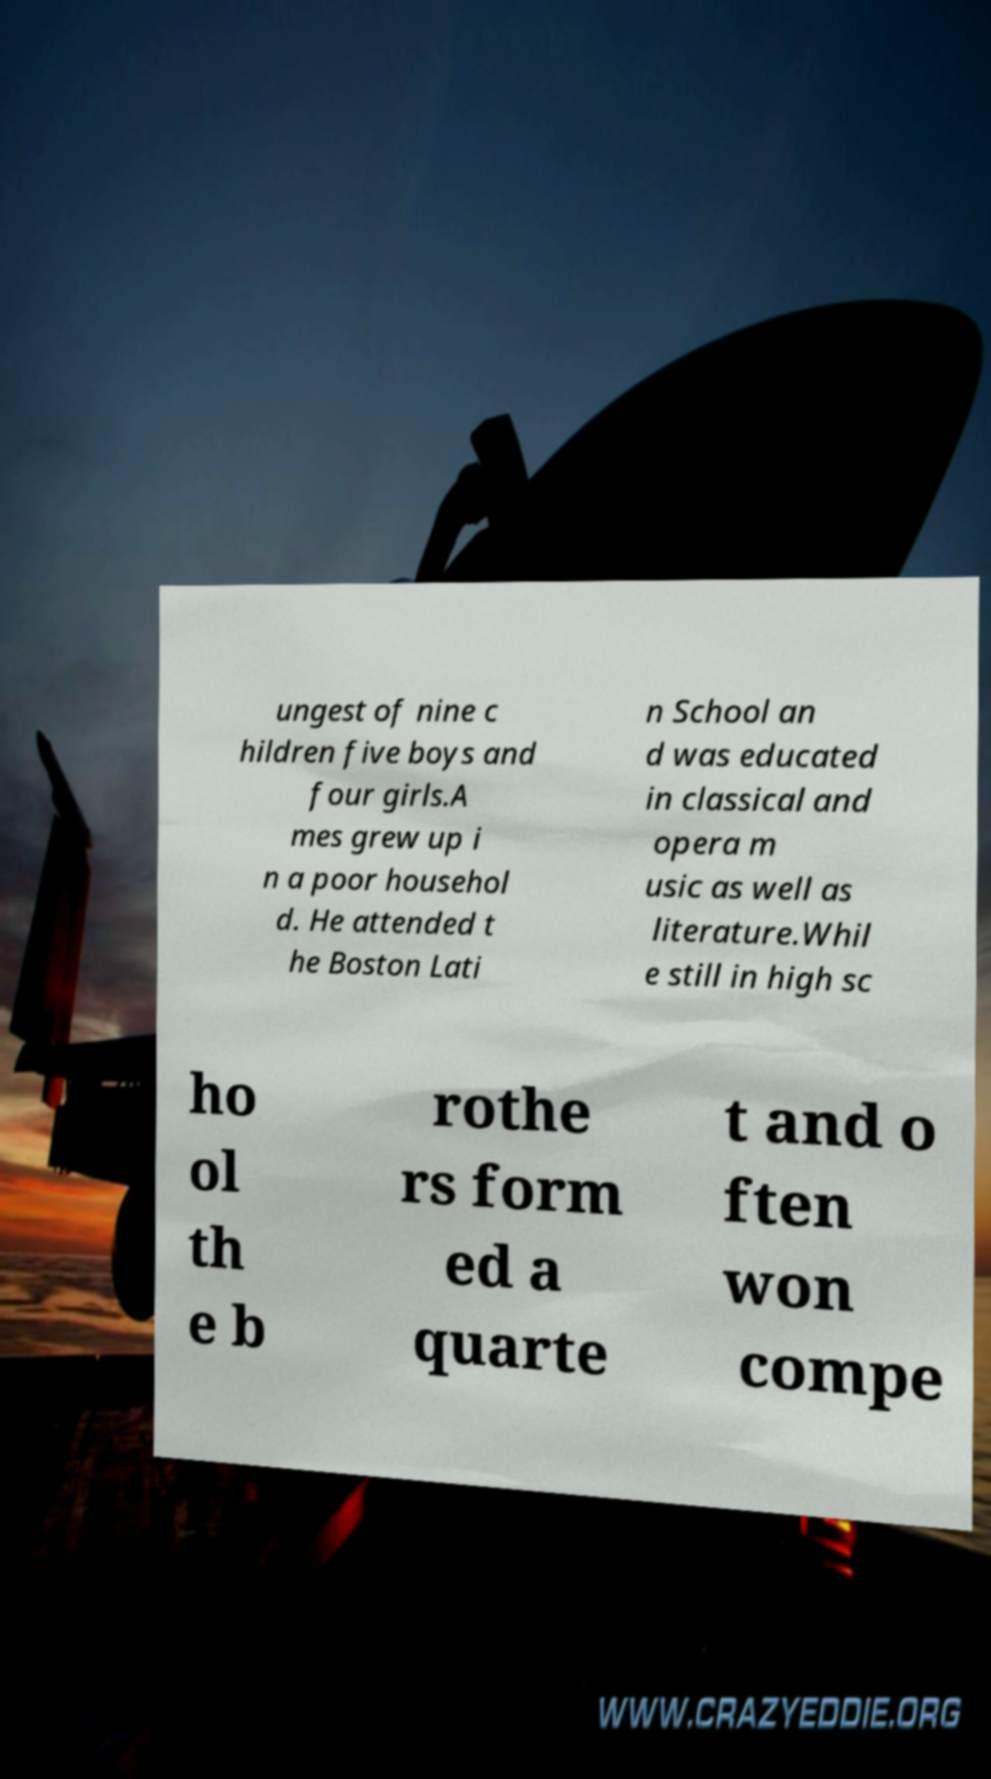Please read and relay the text visible in this image. What does it say? ungest of nine c hildren five boys and four girls.A mes grew up i n a poor househol d. He attended t he Boston Lati n School an d was educated in classical and opera m usic as well as literature.Whil e still in high sc ho ol th e b rothe rs form ed a quarte t and o ften won compe 